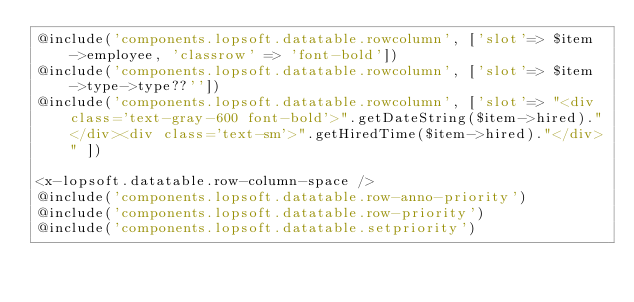<code> <loc_0><loc_0><loc_500><loc_500><_PHP_>@include('components.lopsoft.datatable.rowcolumn', ['slot'=> $item->employee, 'classrow' => 'font-bold'])
@include('components.lopsoft.datatable.rowcolumn', ['slot'=> $item->type->type??''])
@include('components.lopsoft.datatable.rowcolumn', ['slot'=> "<div class='text-gray-600 font-bold'>".getDateString($item->hired)."</div><div class='text-sm'>".getHiredTime($item->hired)."</div>" ])

<x-lopsoft.datatable.row-column-space />
@include('components.lopsoft.datatable.row-anno-priority')
@include('components.lopsoft.datatable.row-priority')
@include('components.lopsoft.datatable.setpriority')
</code> 